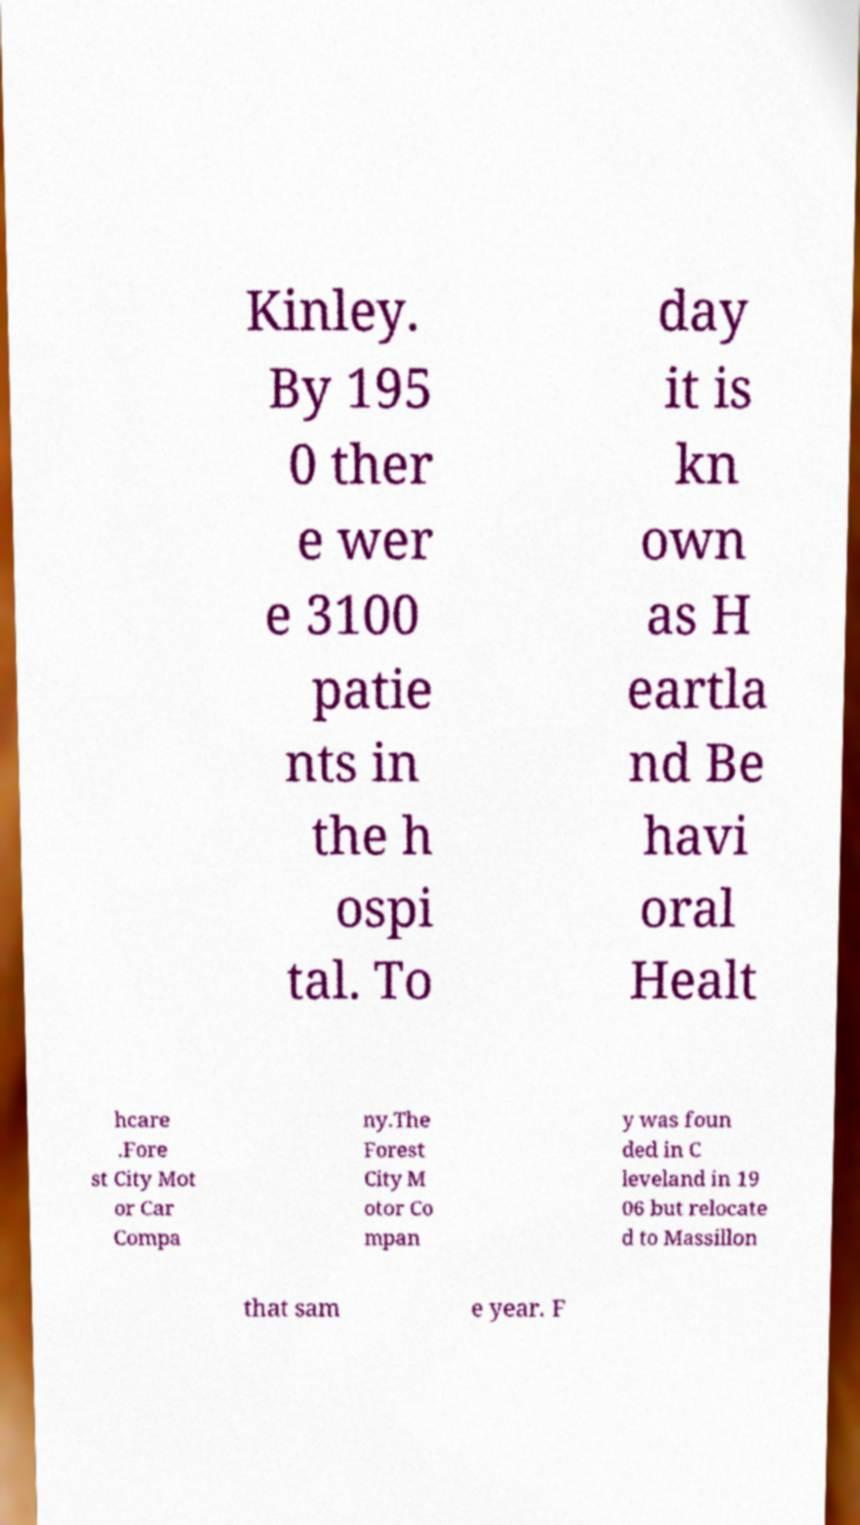Please read and relay the text visible in this image. What does it say? Kinley. By 195 0 ther e wer e 3100 patie nts in the h ospi tal. To day it is kn own as H eartla nd Be havi oral Healt hcare .Fore st City Mot or Car Compa ny.The Forest City M otor Co mpan y was foun ded in C leveland in 19 06 but relocate d to Massillon that sam e year. F 